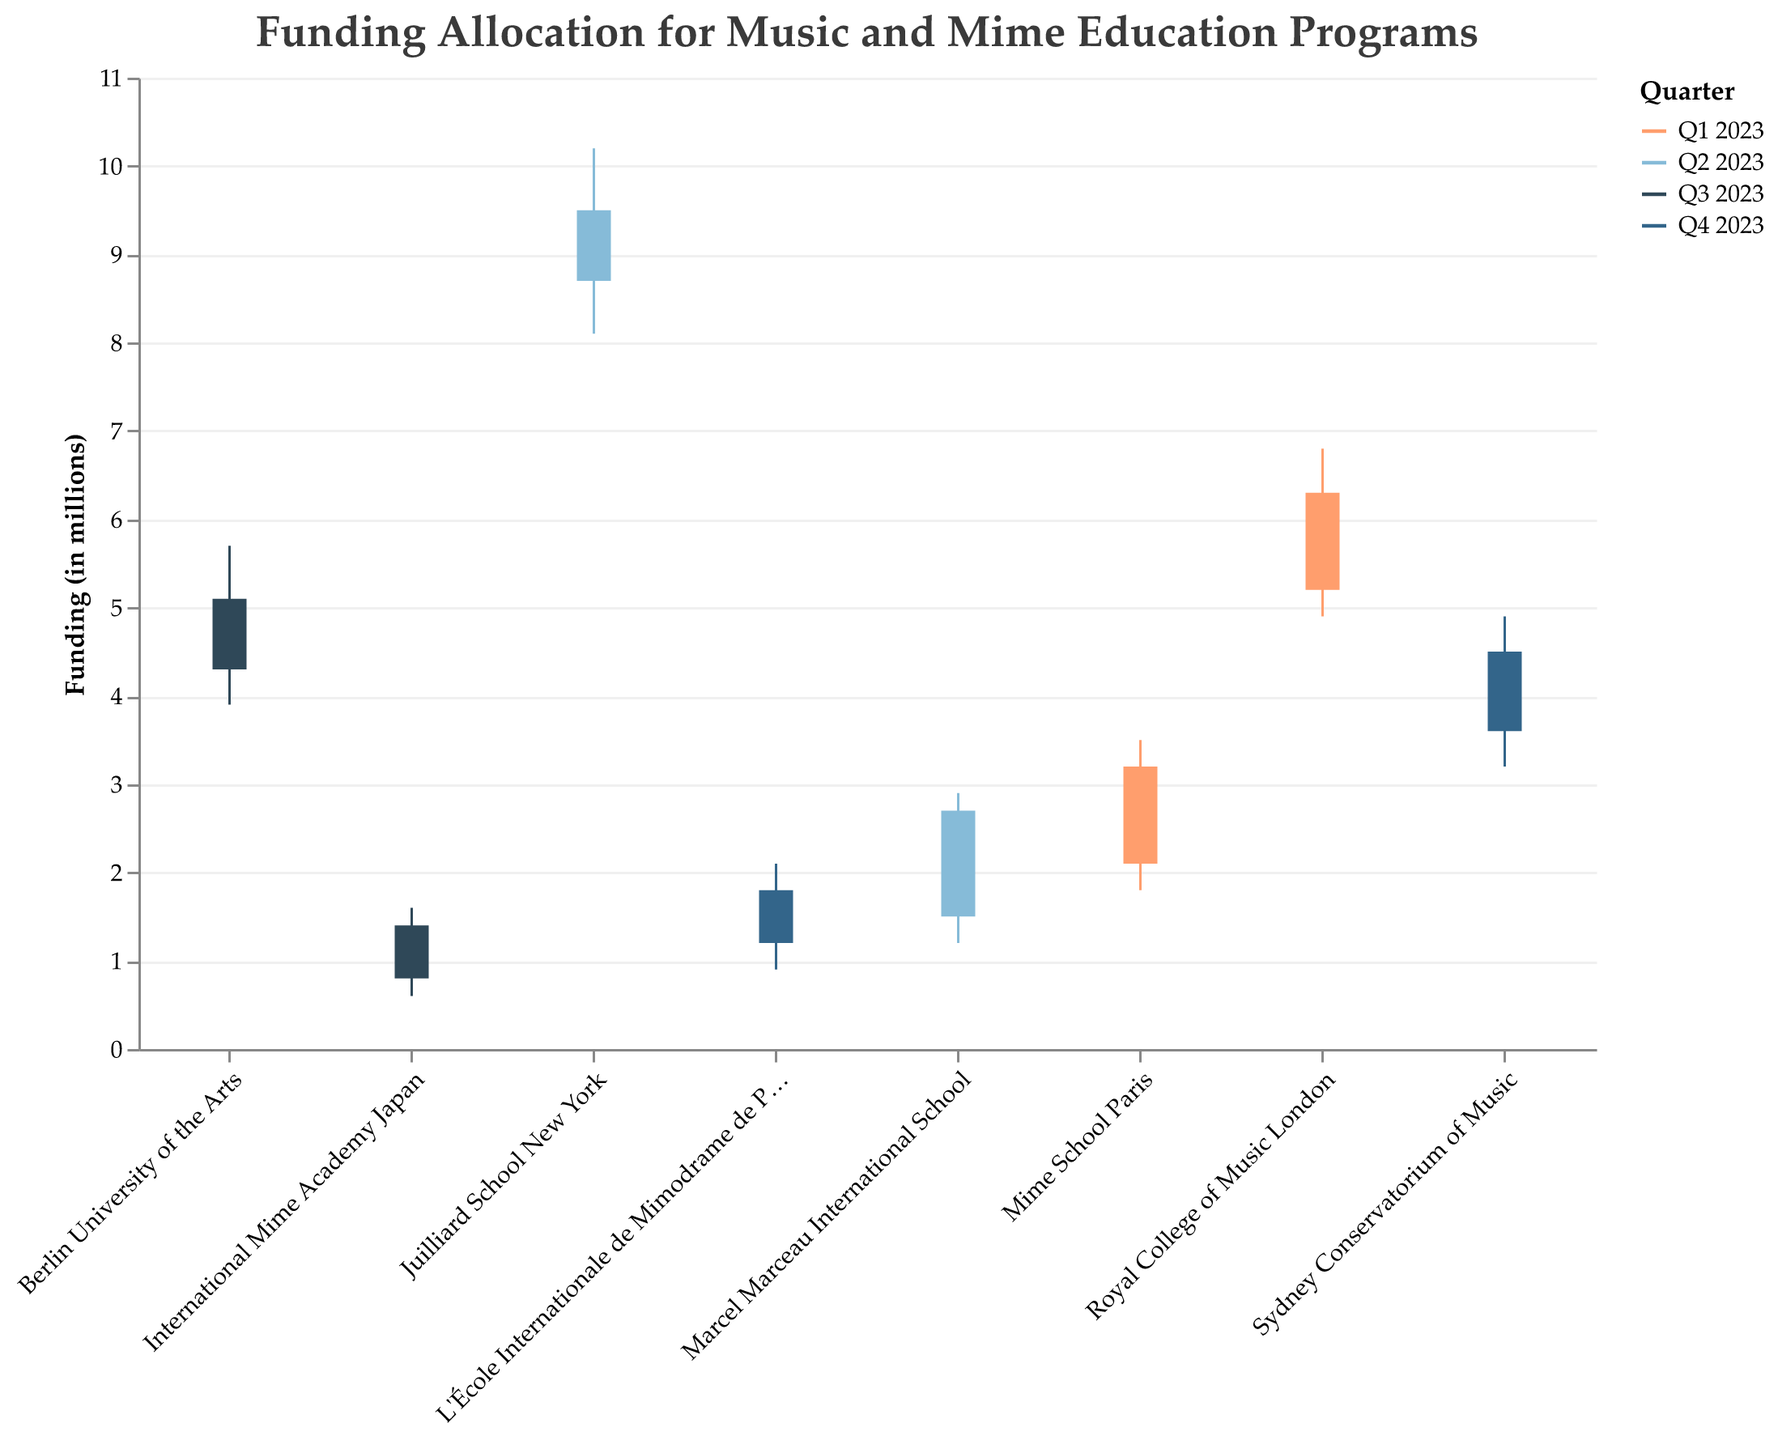Which program had the highest funding allocation in Q2 2023? The Juilliard School New York had the highest funding allocation in Q2 2023 with a high value of 10.2 million. This can be seen by looking at each program’s high value for Q2 2023
Answer: Juilliard School New York What was the funding allocation increase for Sydney Conservatorium of Music in Q4 2023? The open value for Sydney Conservatorium of Music in Q4 2023 was 3.6 million and the close value was 4.5 million. The increase is calculated as 4.5 - 3.6
Answer: 0.9 million Which program experienced the lowest funding allocation across all quarters? The lowest funding allocation was for International Mime Academy Japan in Q3 2023 with a low value of 0.6 million. This can be seen by comparing the low values for each program across all quarters
Answer: International Mime Academy Japan How much did the funding allocation for Mime School Paris increase from open to close in Q1 2023? The open value for Mime School Paris in Q1 2023 was 2.1 million and the close value was 3.2 million. The increase is calculated as 3.2 - 2.1
Answer: 1.1 million Which program had the largest difference between the high and low values in Q3 2023? In Q3 2023, Berlin University of the Arts had the largest difference between the high and low values with a difference of 5.7 - 3.9
Answer: Berlin University of the Arts What is the average high value for programs in Q4 2023? In Q4 2023, the high values are 4.9 for Sydney Conservatorium of Music and 2.1 for L'École Internationale de Mimodrame de Paris. The average is calculated as (4.9 + 2.1) / 2
Answer: 3.5 Which program had the smallest change in funding allocation from open to close in Q2 2023? The smallest change is observed for Marcel Marceau International School in Q2 2023 with a change of 2.7 - 1.5 = 1.2
Answer: Marcel Marceau International School In which quarter did funding allocation for International Mime Academy Japan increase the most from low to high? In Q3 2023, International Mime Academy Japan had a low value of 0.6 and a high value of 1.6, resulting in an increase of 1.6 - 0.6
Answer: Q3 2023 What was the total funding allocation change for Royal College of Music London over Q1 2023? The open value for Royal College of Music London in Q1 2023 was 5.2 million and the close value was 6.3 million. The total change is calculated as 6.3 - 5.2
Answer: 1.1 million 